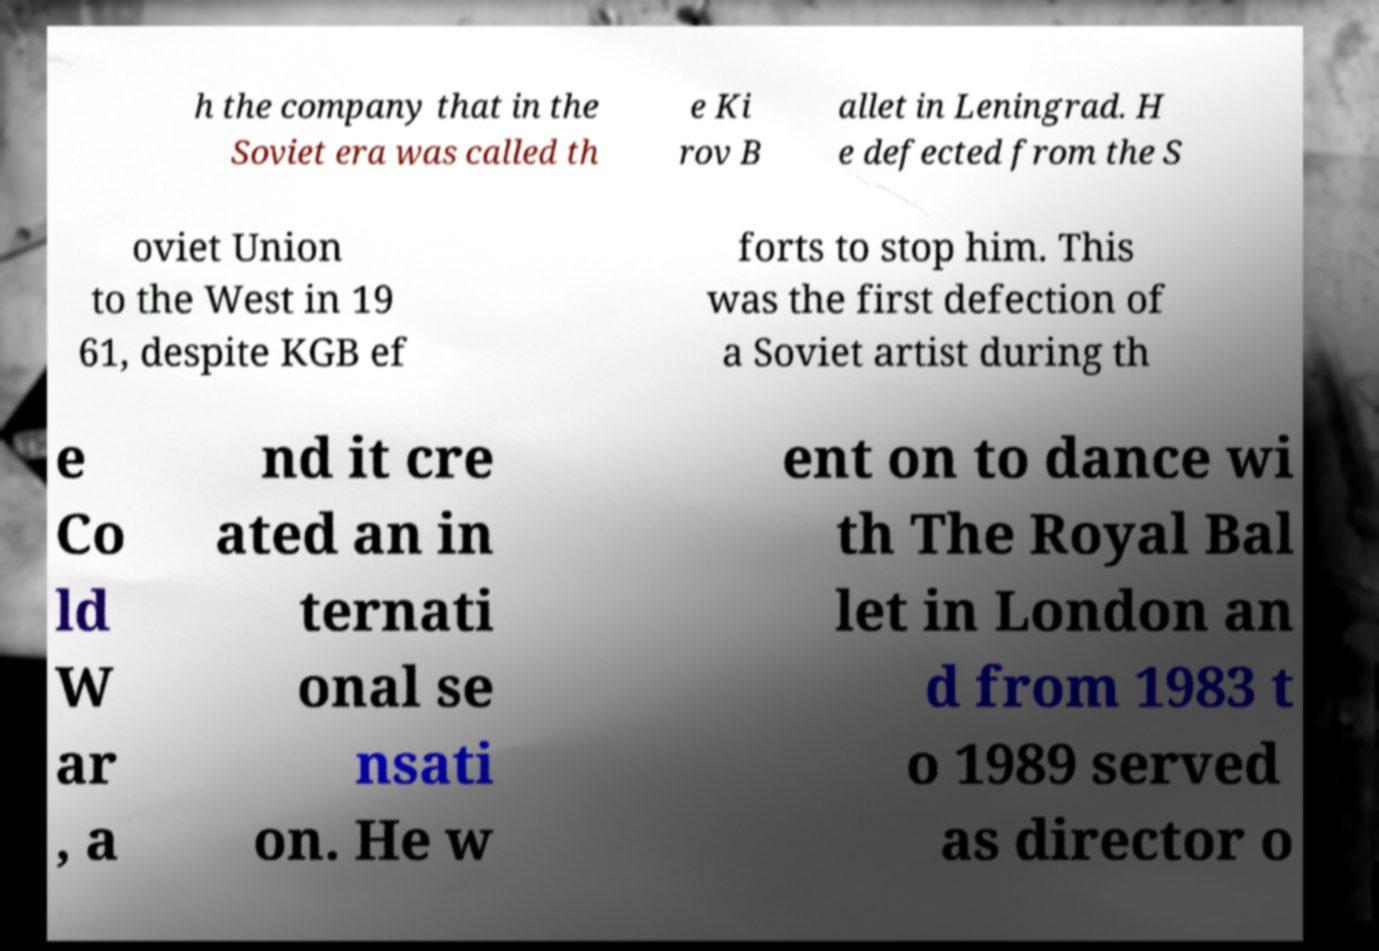For documentation purposes, I need the text within this image transcribed. Could you provide that? h the company that in the Soviet era was called th e Ki rov B allet in Leningrad. H e defected from the S oviet Union to the West in 19 61, despite KGB ef forts to stop him. This was the first defection of a Soviet artist during th e Co ld W ar , a nd it cre ated an in ternati onal se nsati on. He w ent on to dance wi th The Royal Bal let in London an d from 1983 t o 1989 served as director o 